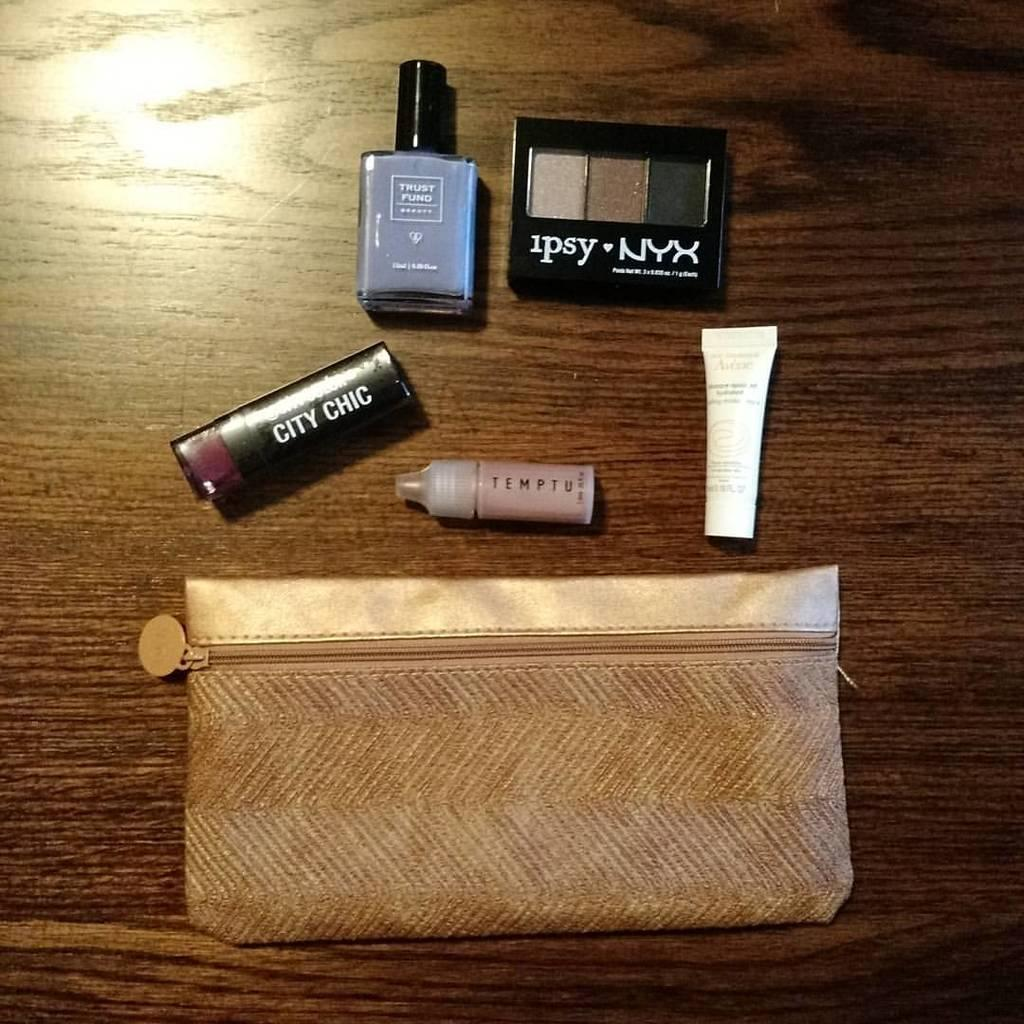<image>
Share a concise interpretation of the image provided. Small pink Temptu bottle to the right of a small City Chic lipstick. 